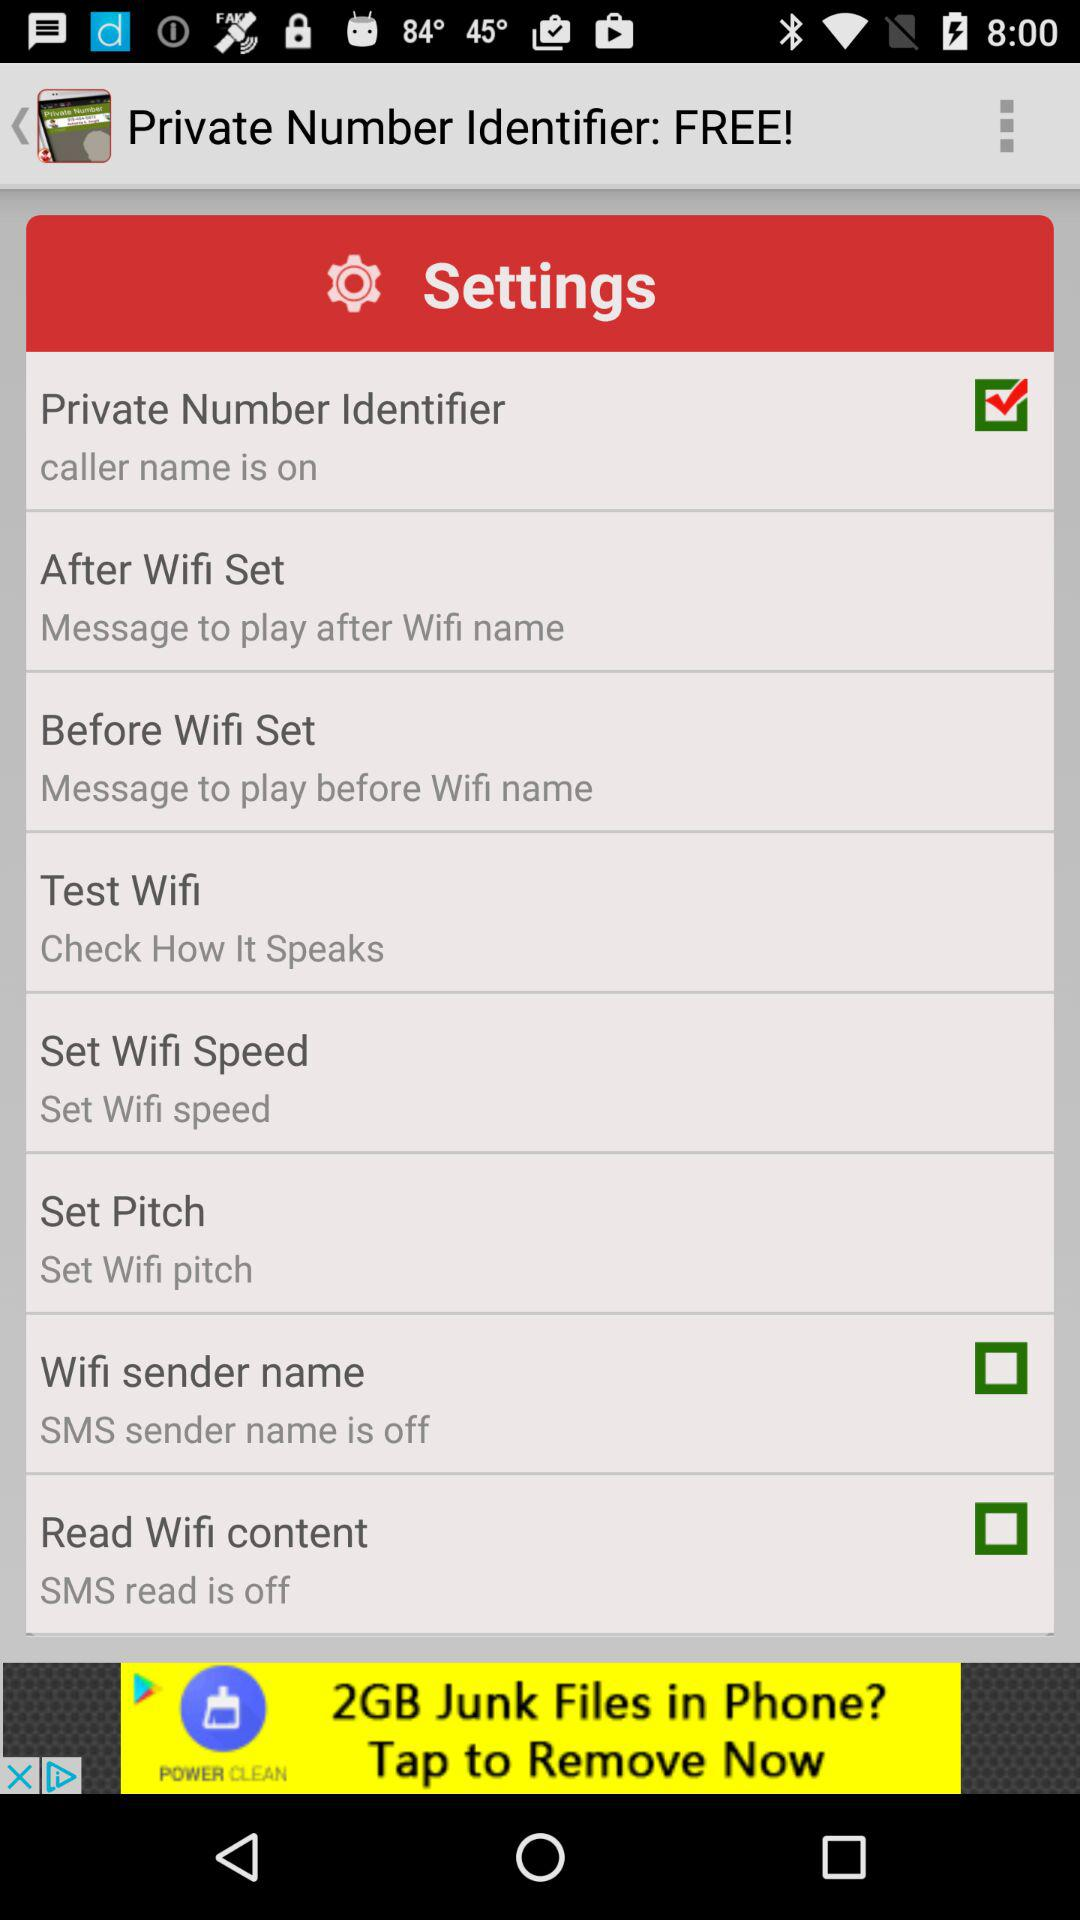What is the application name? The application name is "Private Number Identifier: FREE!". 